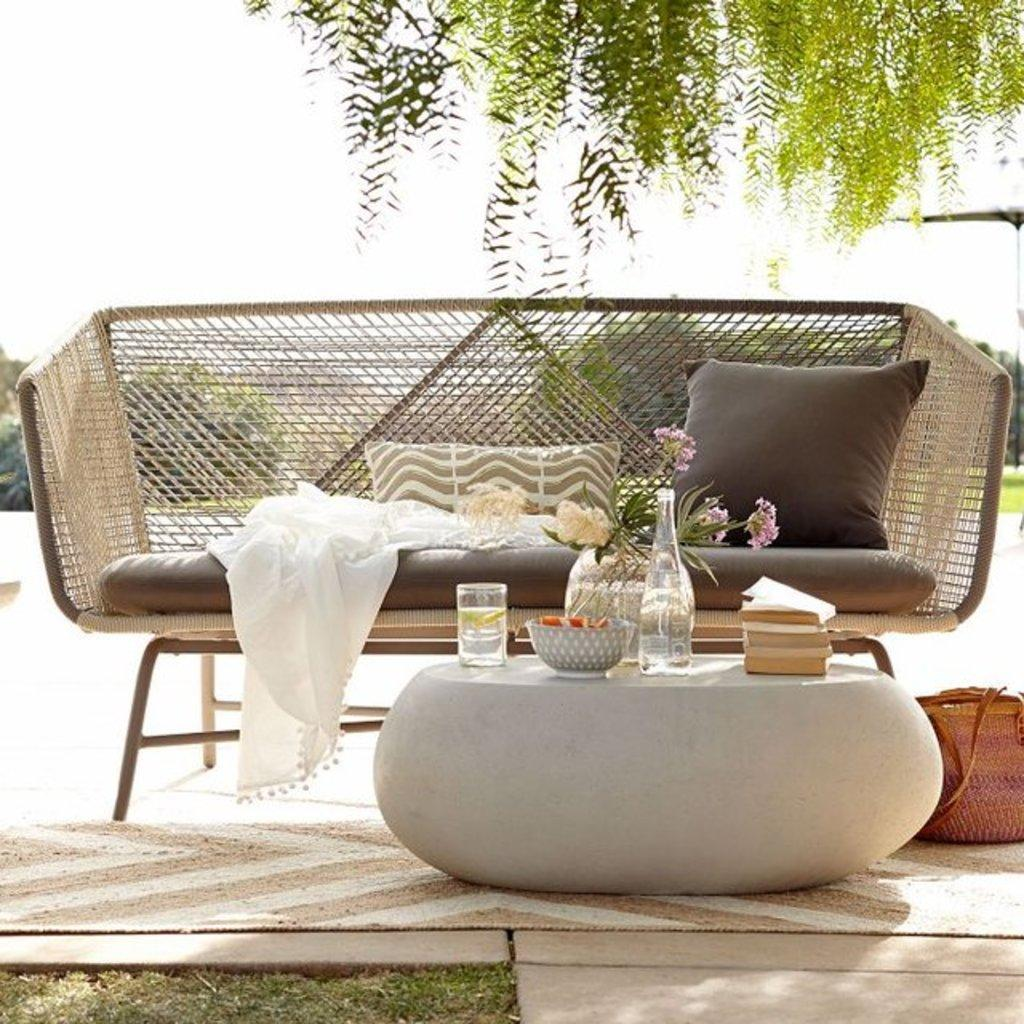Where was the image taken? The image was clicked outside on a lawn. What type of furniture is present in the image? There is a wooden sofa with cushion pillows in the image. Is there any other furniture or object near the wooden sofa? Yes, there is a table in front of the sofa. What items can be seen on the table? The table has a flower vase, a bowl, and a glass on it. What is the natural element visible above the table? There is a tree above the table. Can you see a branch from the tree touching the glass on the table? There is no mention of a branch touching the glass in the image. Is there a railway visible in the image? No, there is no railway present in the image. 